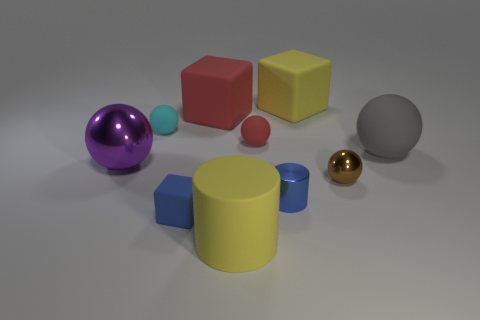There is a cube that is the same color as the big cylinder; what is its size?
Your response must be concise. Large. The purple shiny object has what size?
Your answer should be very brief. Large. There is a small metal thing that is the same shape as the big gray thing; what color is it?
Provide a succinct answer. Brown. Are there any other things of the same color as the tiny metal sphere?
Offer a very short reply. No. There is a cyan matte thing to the left of the red sphere; is its size the same as the cylinder that is behind the small rubber cube?
Your answer should be compact. Yes. Are there an equal number of small blue matte objects on the right side of the small metallic ball and small objects that are behind the gray thing?
Your answer should be compact. No. Does the blue matte object have the same size as the red matte object in front of the cyan rubber ball?
Your answer should be compact. Yes. Is there a cylinder behind the yellow object in front of the blue metallic cylinder?
Ensure brevity in your answer.  Yes. Is there a large rubber object of the same shape as the tiny blue matte thing?
Provide a short and direct response. Yes. How many big yellow cylinders are in front of the cube that is in front of the big sphere on the right side of the small blue metallic thing?
Your answer should be very brief. 1. 